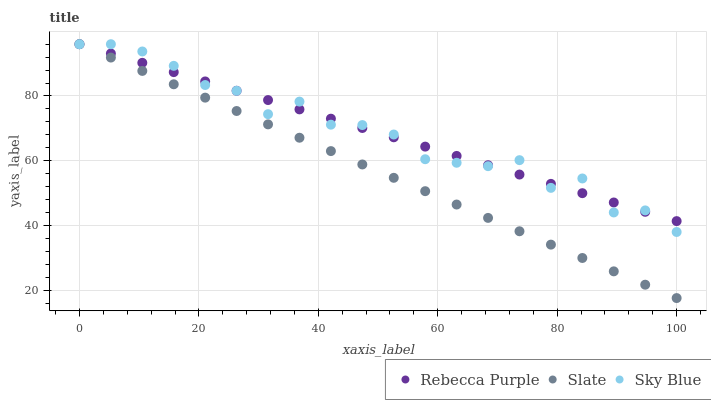Does Slate have the minimum area under the curve?
Answer yes or no. Yes. Does Sky Blue have the maximum area under the curve?
Answer yes or no. Yes. Does Rebecca Purple have the minimum area under the curve?
Answer yes or no. No. Does Rebecca Purple have the maximum area under the curve?
Answer yes or no. No. Is Rebecca Purple the smoothest?
Answer yes or no. Yes. Is Sky Blue the roughest?
Answer yes or no. Yes. Is Slate the smoothest?
Answer yes or no. No. Is Slate the roughest?
Answer yes or no. No. Does Slate have the lowest value?
Answer yes or no. Yes. Does Rebecca Purple have the lowest value?
Answer yes or no. No. Does Rebecca Purple have the highest value?
Answer yes or no. Yes. Does Rebecca Purple intersect Slate?
Answer yes or no. Yes. Is Rebecca Purple less than Slate?
Answer yes or no. No. Is Rebecca Purple greater than Slate?
Answer yes or no. No. 